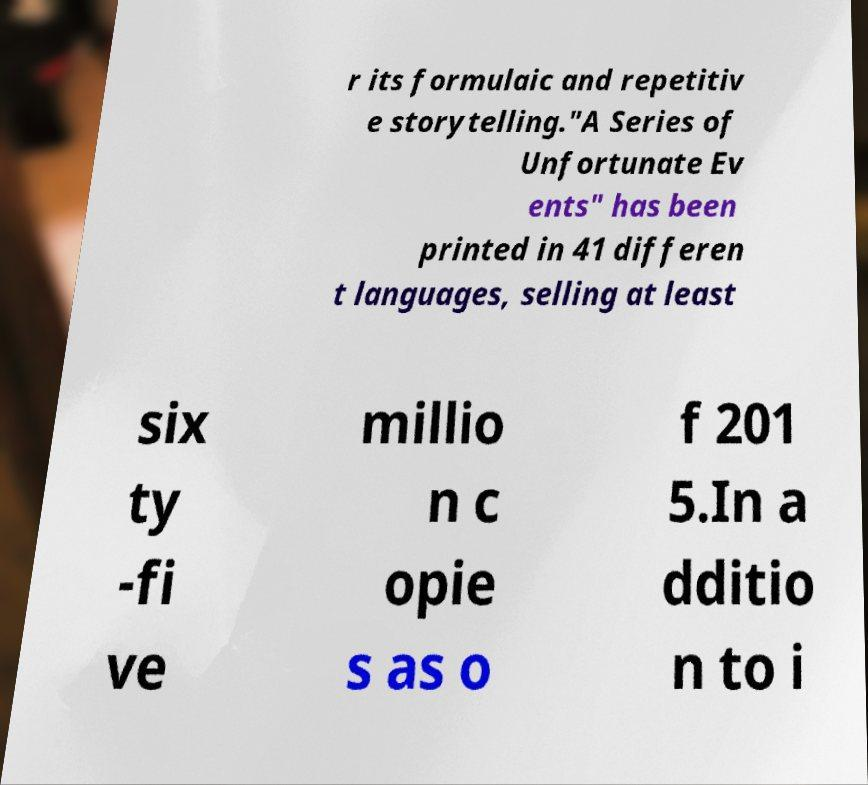What messages or text are displayed in this image? I need them in a readable, typed format. r its formulaic and repetitiv e storytelling."A Series of Unfortunate Ev ents" has been printed in 41 differen t languages, selling at least six ty -fi ve millio n c opie s as o f 201 5.In a dditio n to i 